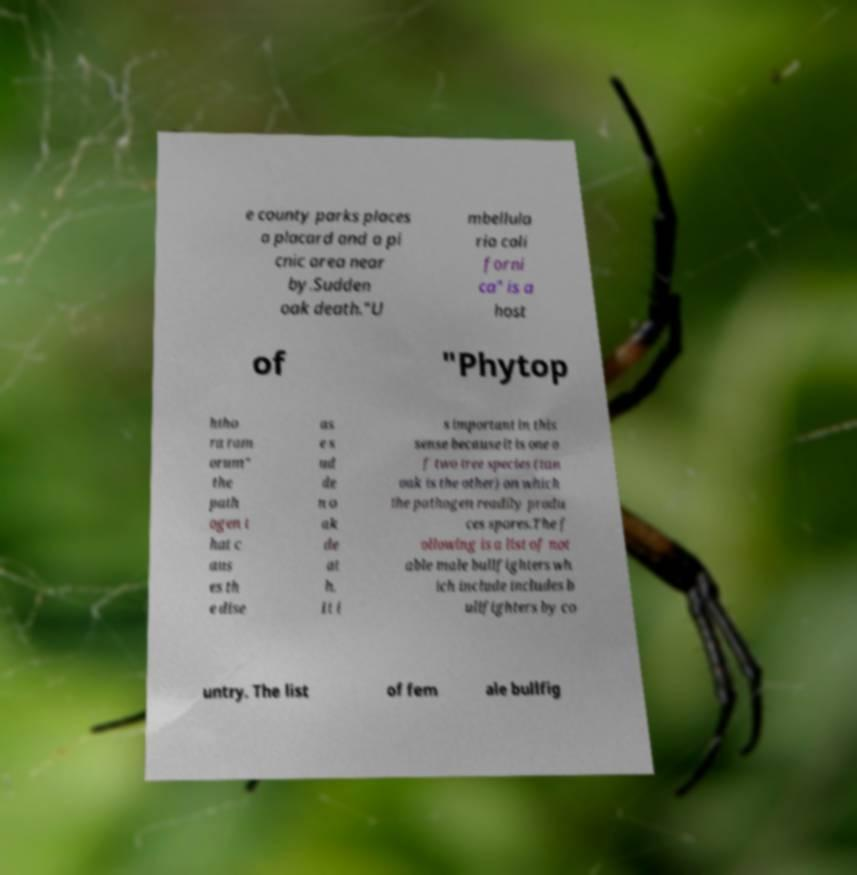Can you read and provide the text displayed in the image?This photo seems to have some interesting text. Can you extract and type it out for me? e county parks places a placard and a pi cnic area near by.Sudden oak death."U mbellula ria cali forni ca" is a host of "Phytop htho ra ram orum" the path ogen t hat c aus es th e dise as e s ud de n o ak de at h. It i s important in this sense because it is one o f two tree species (tan oak is the other) on which the pathogen readily produ ces spores.The f ollowing is a list of not able male bullfighters wh ich include includes b ullfighters by co untry. The list of fem ale bullfig 